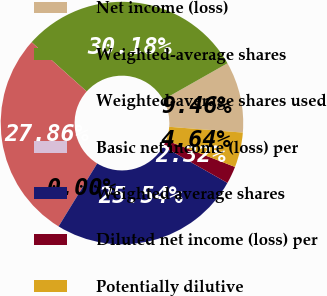Convert chart. <chart><loc_0><loc_0><loc_500><loc_500><pie_chart><fcel>Net income (loss)<fcel>Weighted-average shares<fcel>Weighted-average shares used<fcel>Basic net income (loss) per<fcel>Weighted average shares<fcel>Diluted net income (loss) per<fcel>Potentially dilutive<nl><fcel>9.46%<fcel>30.18%<fcel>27.86%<fcel>0.0%<fcel>25.54%<fcel>2.32%<fcel>4.64%<nl></chart> 